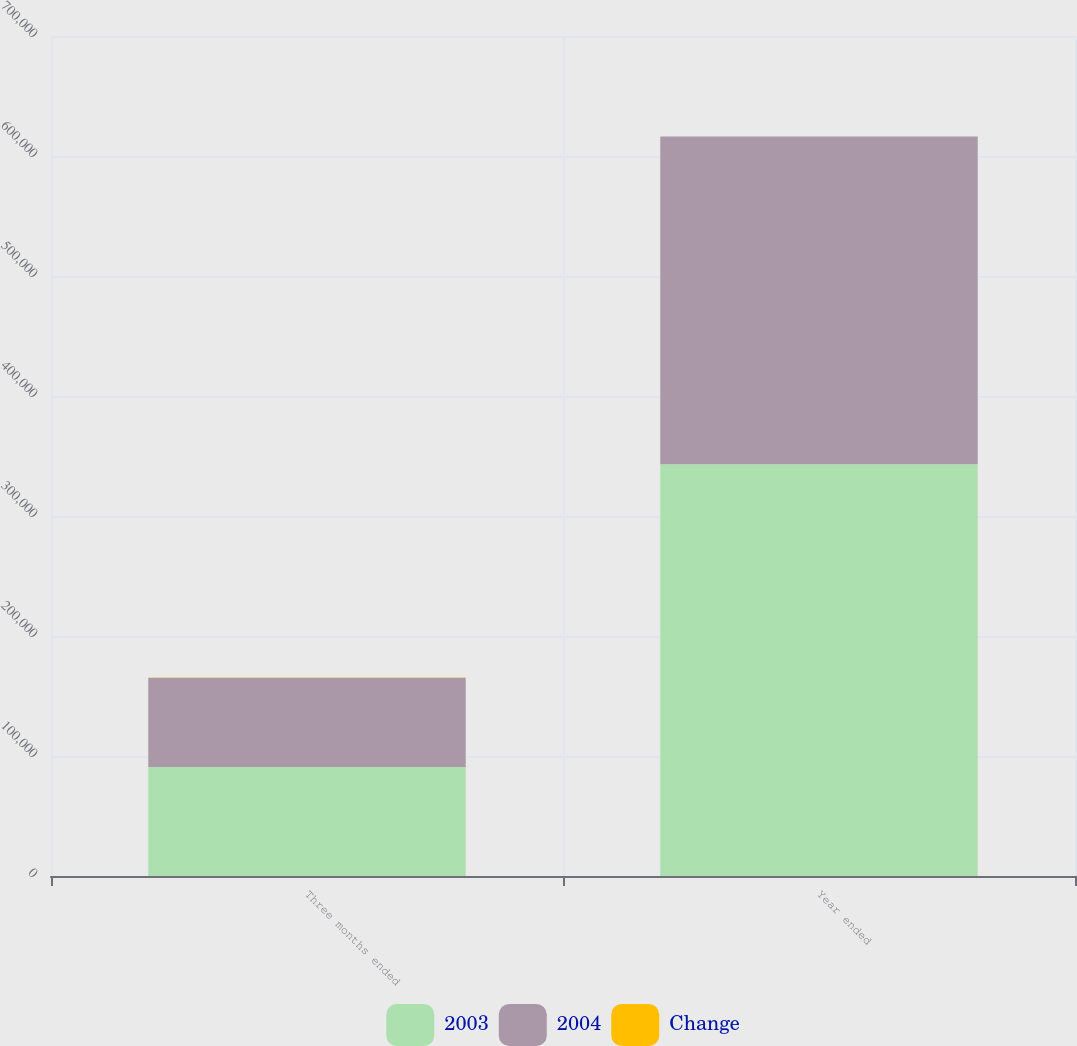<chart> <loc_0><loc_0><loc_500><loc_500><stacked_bar_chart><ecel><fcel>Three months ended<fcel>Year ended<nl><fcel>2003<fcel>90895<fcel>343159<nl><fcel>2004<fcel>74397<fcel>273077<nl><fcel>Change<fcel>22.2<fcel>25.7<nl></chart> 